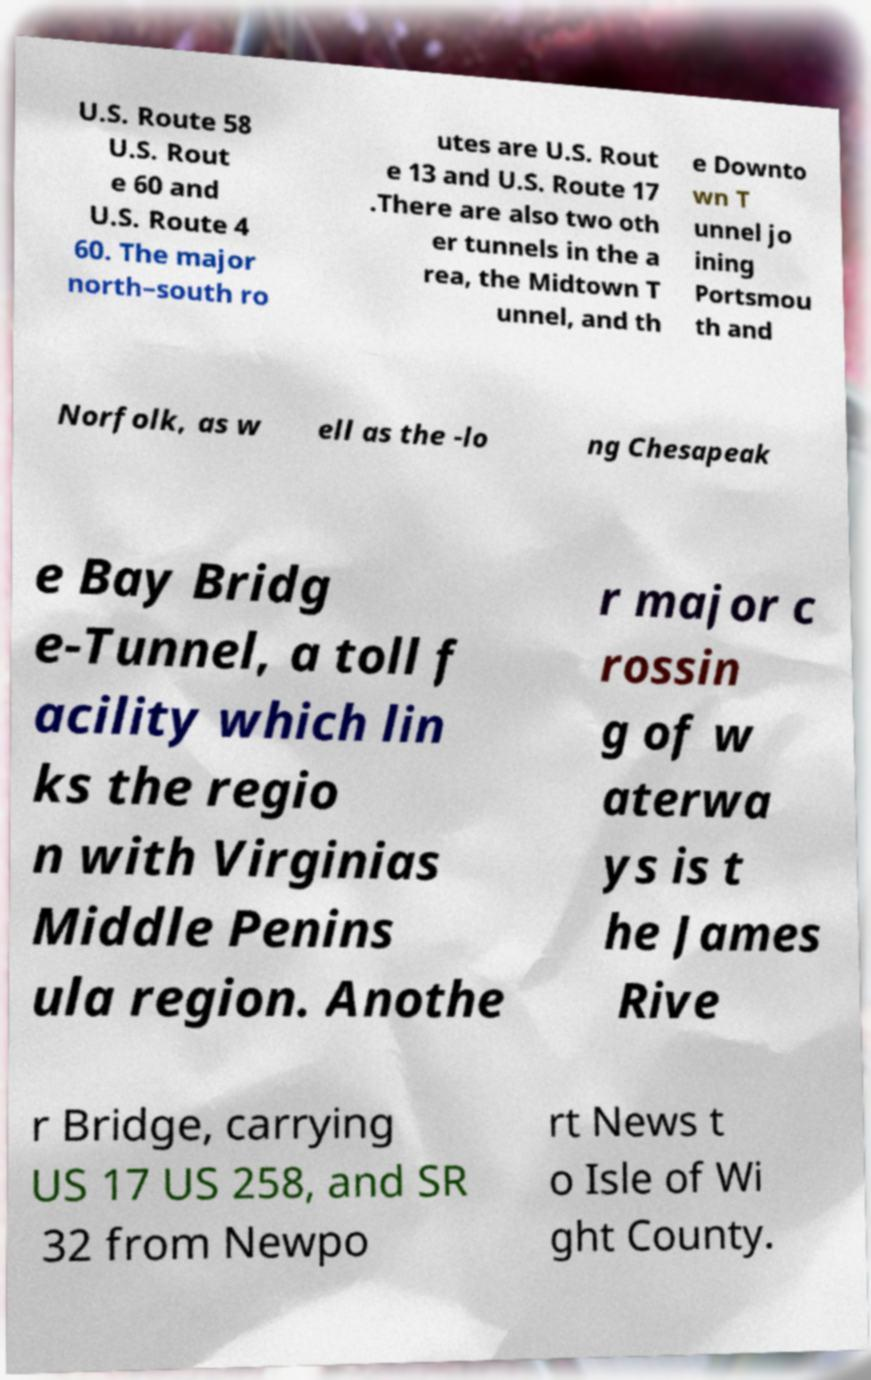Please identify and transcribe the text found in this image. U.S. Route 58 U.S. Rout e 60 and U.S. Route 4 60. The major north–south ro utes are U.S. Rout e 13 and U.S. Route 17 .There are also two oth er tunnels in the a rea, the Midtown T unnel, and th e Downto wn T unnel jo ining Portsmou th and Norfolk, as w ell as the -lo ng Chesapeak e Bay Bridg e-Tunnel, a toll f acility which lin ks the regio n with Virginias Middle Penins ula region. Anothe r major c rossin g of w aterwa ys is t he James Rive r Bridge, carrying US 17 US 258, and SR 32 from Newpo rt News t o Isle of Wi ght County. 